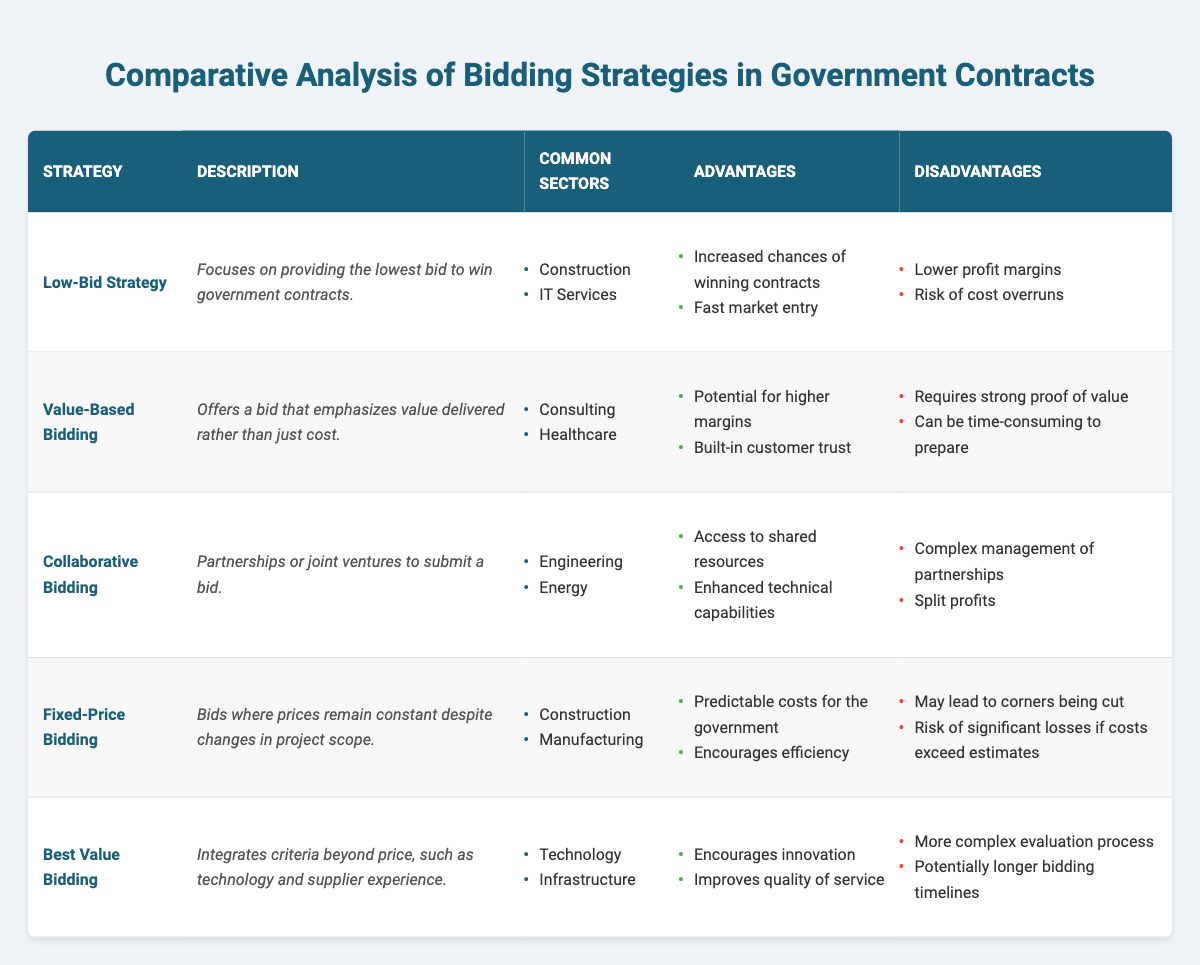What are the common sectors for the Low-Bid Strategy? The table lists "Construction" and "IT Services" as the common sectors for the Low-Bid Strategy.
Answer: Construction, IT Services Which strategy has the advantage of built-in customer trust? The only strategy that mentions "built-in customer trust" as an advantage is Value-Based Bidding.
Answer: Value-Based Bidding Are there any strategies that are commonly used in the Energy sector? The table indicates that the Collaborative Bidding strategy is used in the Energy sector, confirming that it is true.
Answer: Yes What is the main focus of the Best Value Bidding strategy? The Best Value Bidding strategy focuses on integrating criteria beyond price, such as technology and supplier experience.
Answer: Integrating criteria beyond price How many advantages does the Fixed-Price Bidding strategy list? The Fixed-Price Bidding strategy has two advantages listed: "Predictable costs for the government" and "Encourages efficiency." Hence, the total is two.
Answer: Two What is the common disadvantage shared among Low-Bid and Fixed-Price Bidding strategies? Both strategies share the disadvantage of risk associated with cost management: Low-Bid faces "Risk of cost overruns," while Fixed-Price has "Risk of significant losses if costs exceed estimates."
Answer: Risk of cost overruns Which bidding strategy would likely be most beneficial for a project requiring considerable innovation? The Best Value Bidding strategy is most likely to be beneficial for projects requiring innovation, as it encourages innovation and improves quality of service.
Answer: Best Value Bidding What is the average number of disadvantages listed for the bidding strategies? There are five strategies, each listed with two disadvantages, totaling ten disadvantages. Thus, the average is 10/5 = 2.
Answer: Two Which strategy is primarily focused on the IT Services sector? The Low-Bid Strategy is primarily focused on the IT Services sector according to the table.
Answer: Low-Bid Strategy 